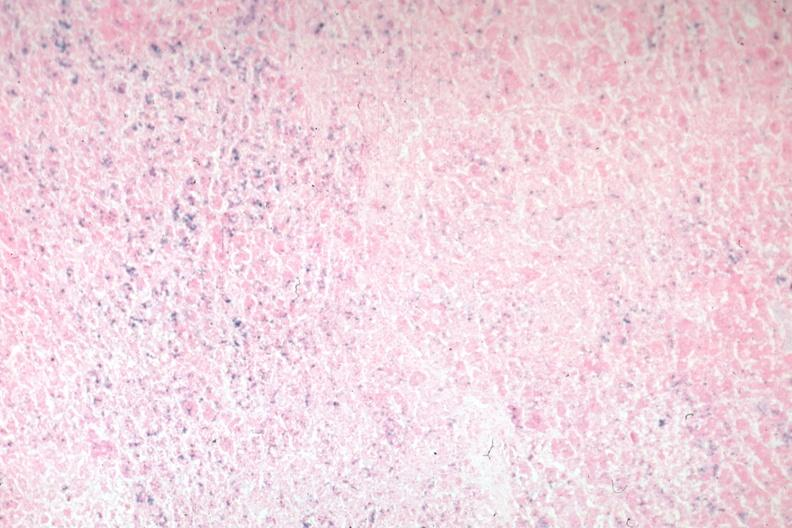what is present?
Answer the question using a single word or phrase. Hemochromatosis 